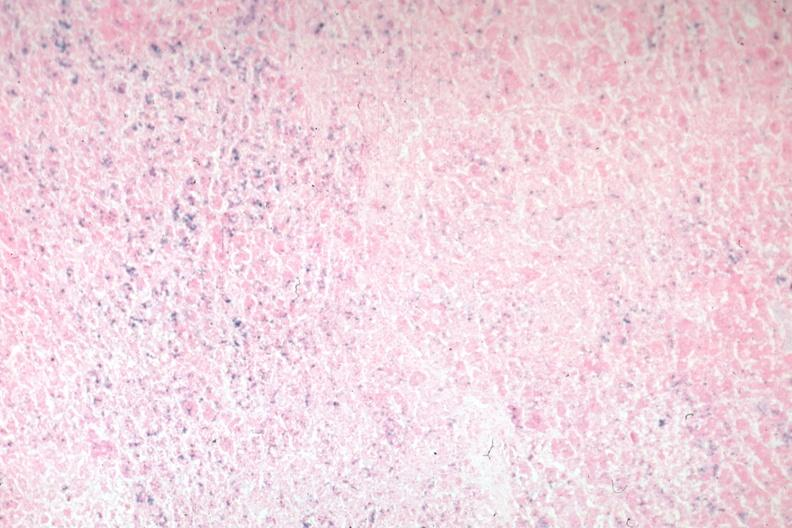what is present?
Answer the question using a single word or phrase. Hemochromatosis 